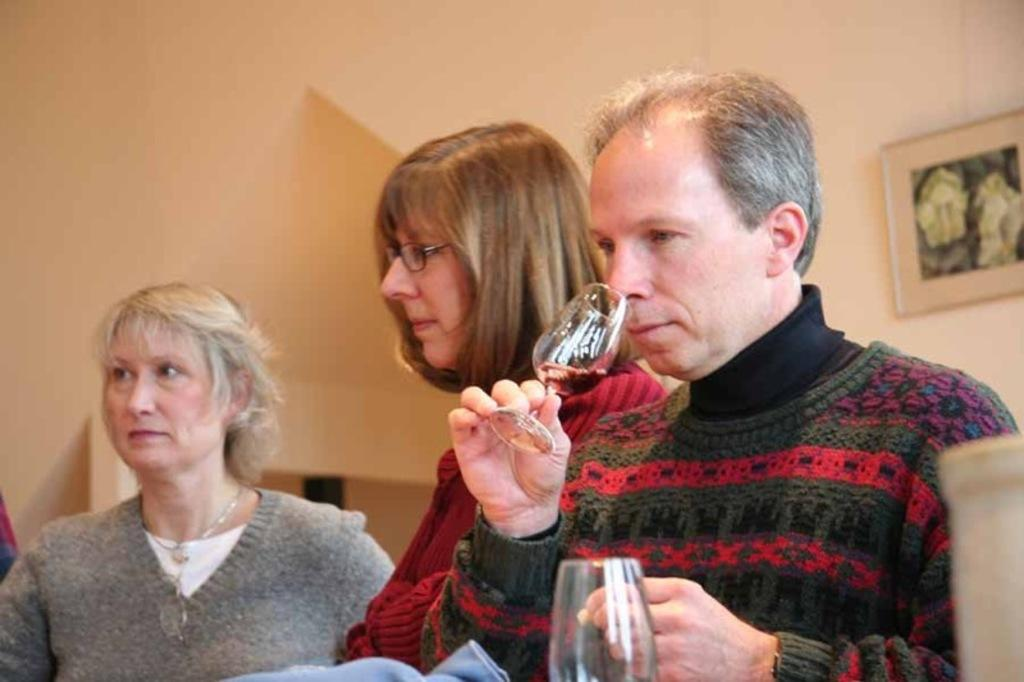How many people are present in the image? There are 3 people standing in the image. What is one person holding in the image? One person is holding a glass of drink. Can you describe the object at the front of the image? There is a glass at the front of the image. What can be seen on the wall in the image? There is a photo frame on the wall in the image. What type of coil is being observed by the people in the image? There is no coil present in the image; it features 3 people standing, one holding a glass of drink, a glass at the front, and a photo frame on the wall. 